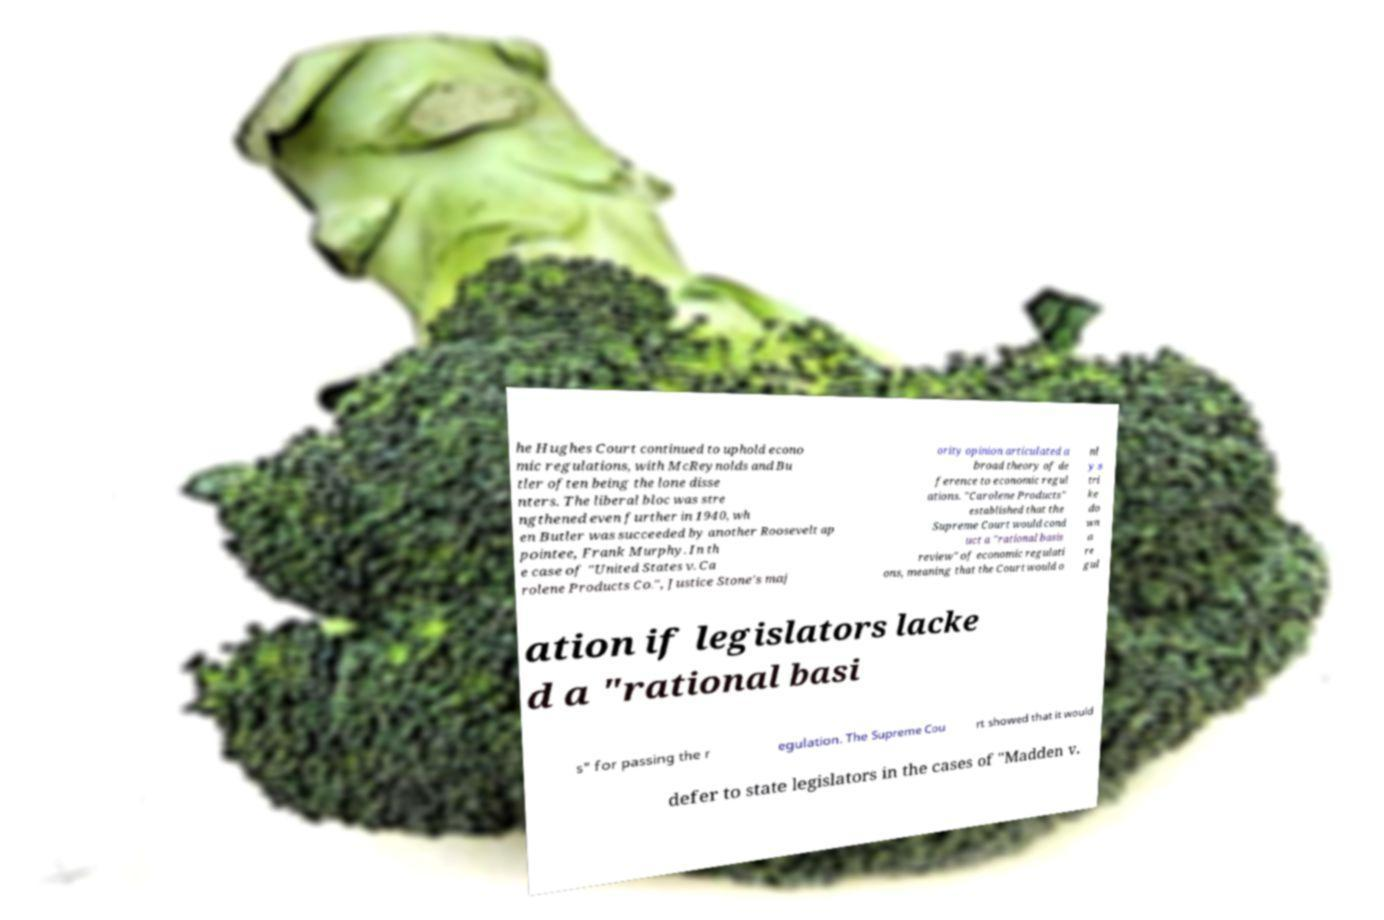Please identify and transcribe the text found in this image. he Hughes Court continued to uphold econo mic regulations, with McReynolds and Bu tler often being the lone disse nters. The liberal bloc was stre ngthened even further in 1940, wh en Butler was succeeded by another Roosevelt ap pointee, Frank Murphy. In th e case of "United States v. Ca rolene Products Co.", Justice Stone's maj ority opinion articulated a broad theory of de ference to economic regul ations. "Carolene Products" established that the Supreme Court would cond uct a "rational basis review" of economic regulati ons, meaning that the Court would o nl y s tri ke do wn a re gul ation if legislators lacke d a "rational basi s" for passing the r egulation. The Supreme Cou rt showed that it would defer to state legislators in the cases of "Madden v. 